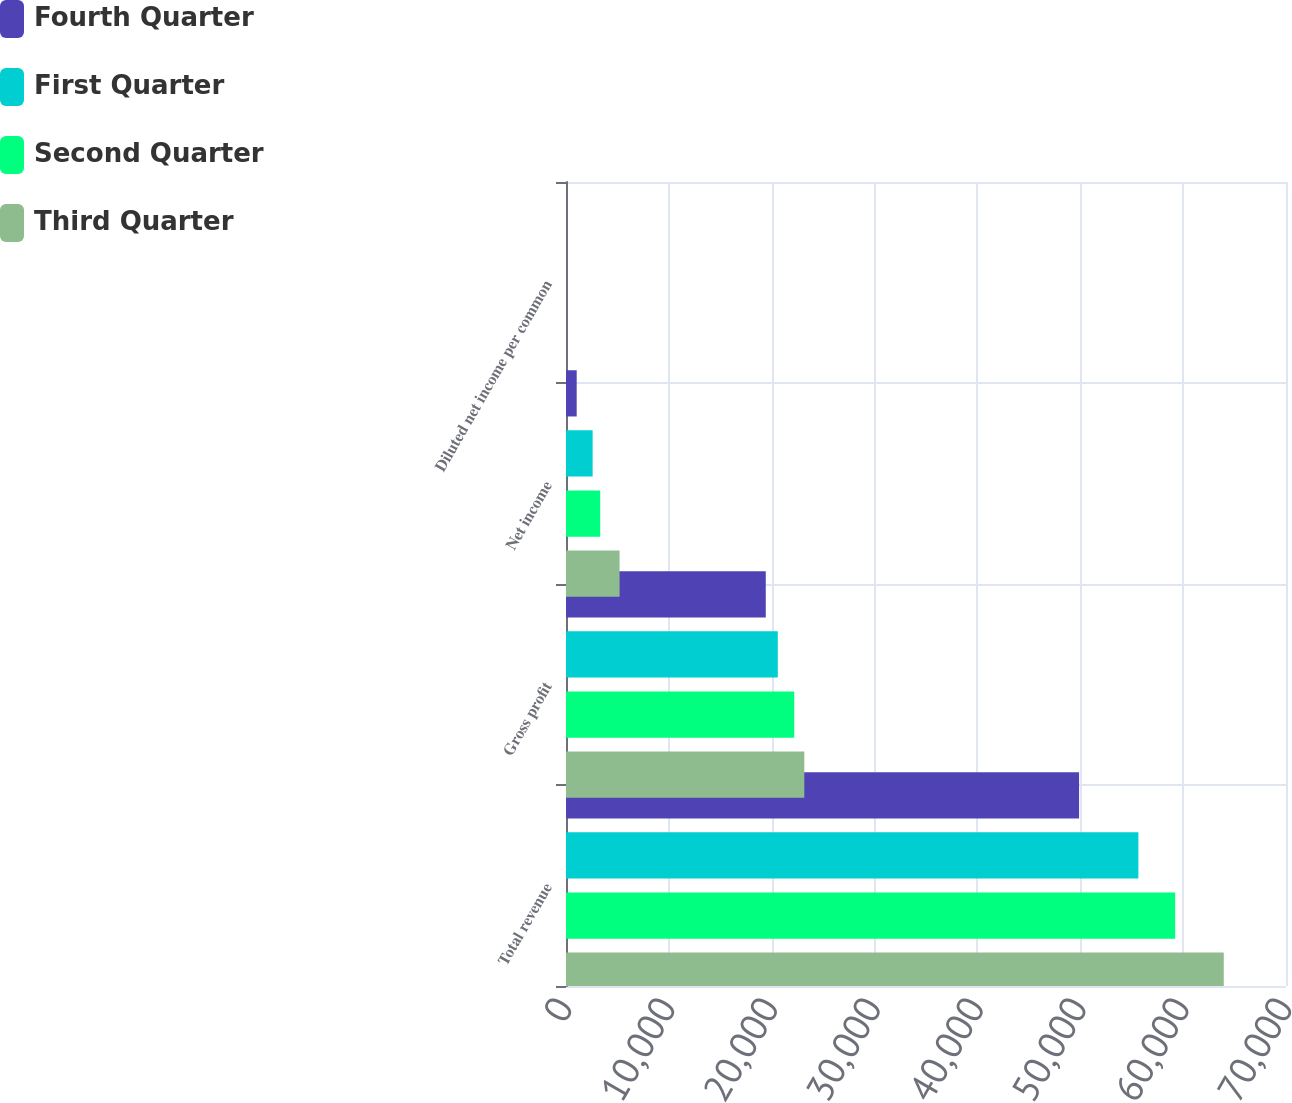Convert chart to OTSL. <chart><loc_0><loc_0><loc_500><loc_500><stacked_bar_chart><ecel><fcel>Total revenue<fcel>Gross profit<fcel>Net income<fcel>Diluted net income per common<nl><fcel>Fourth Quarter<fcel>49882<fcel>19422<fcel>1040<fcel>0.02<nl><fcel>First Quarter<fcel>55648<fcel>20591<fcel>2589<fcel>0.06<nl><fcel>Second Quarter<fcel>59225<fcel>22187<fcel>3325<fcel>0.08<nl><fcel>Third Quarter<fcel>63950<fcel>23169<fcel>5210<fcel>0.12<nl></chart> 